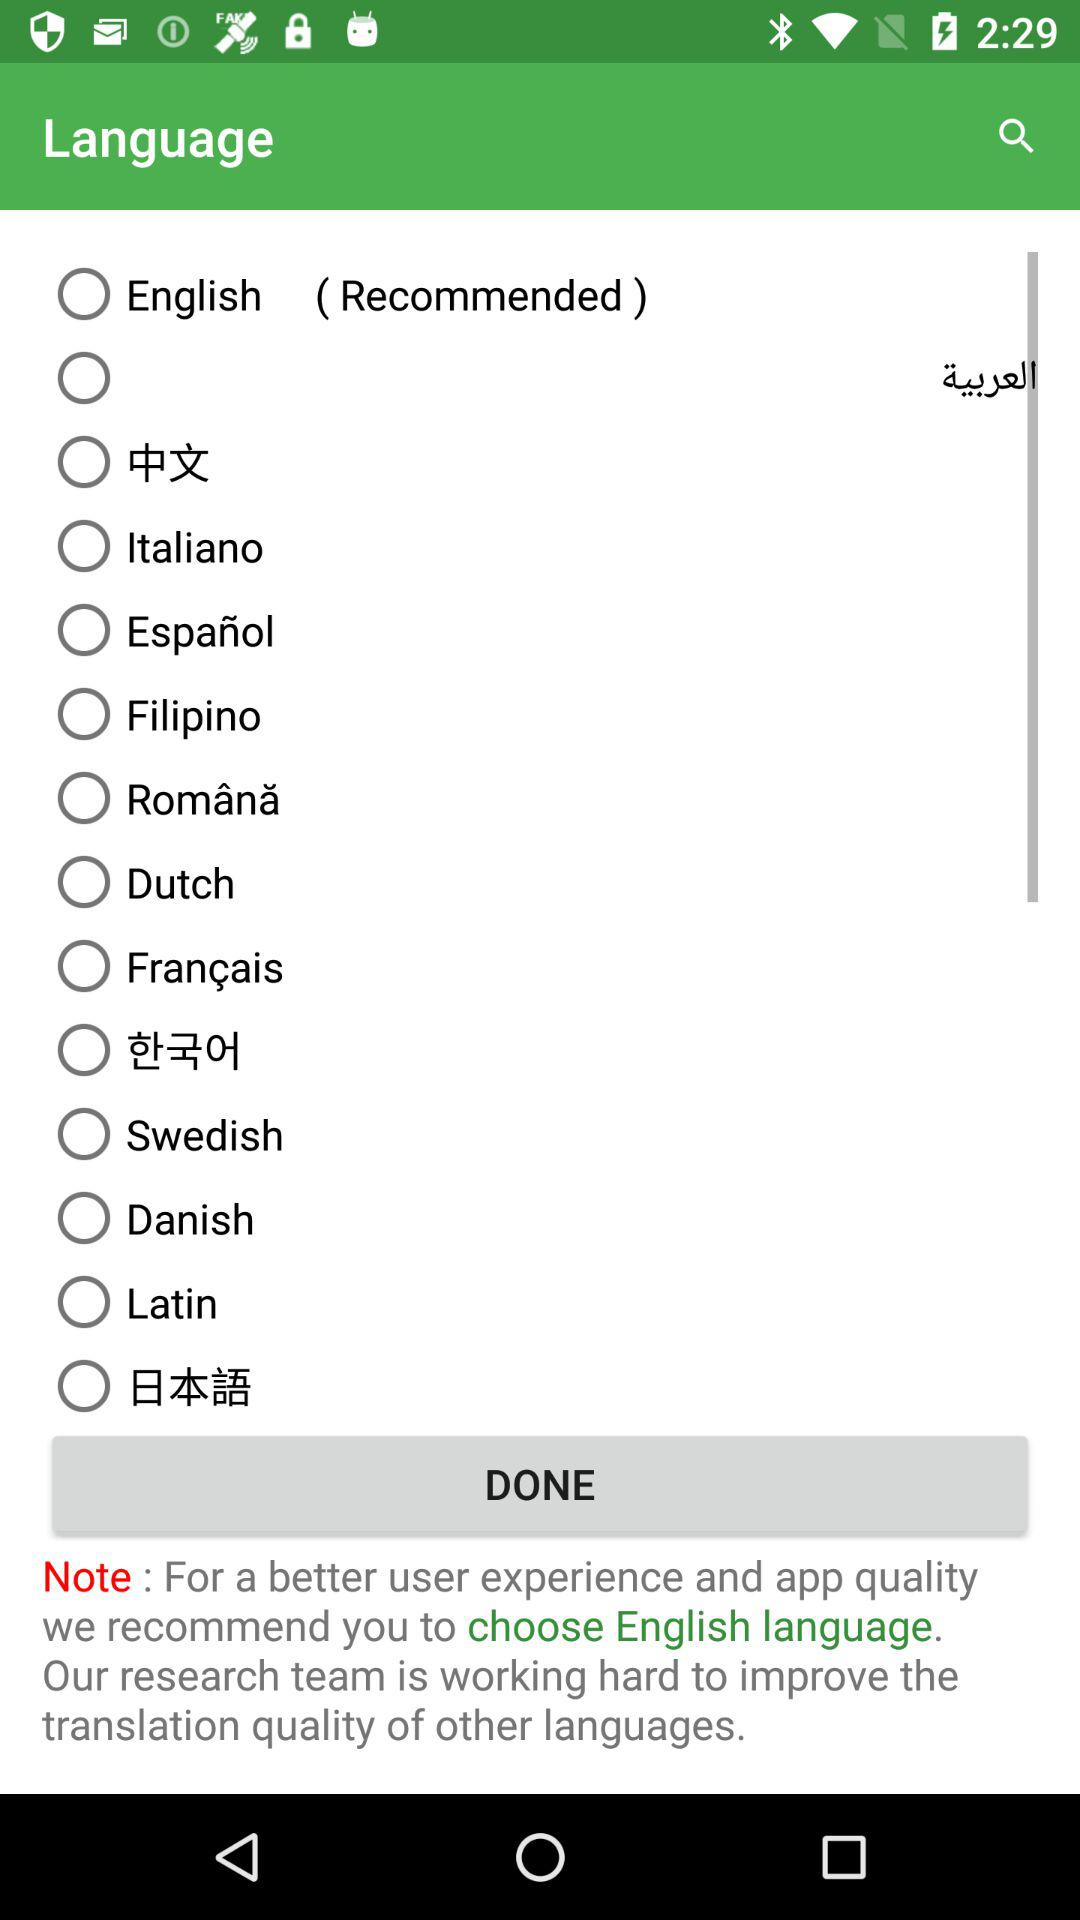Which language is recommended for a better user experience?
Answer the question using a single word or phrase. English 